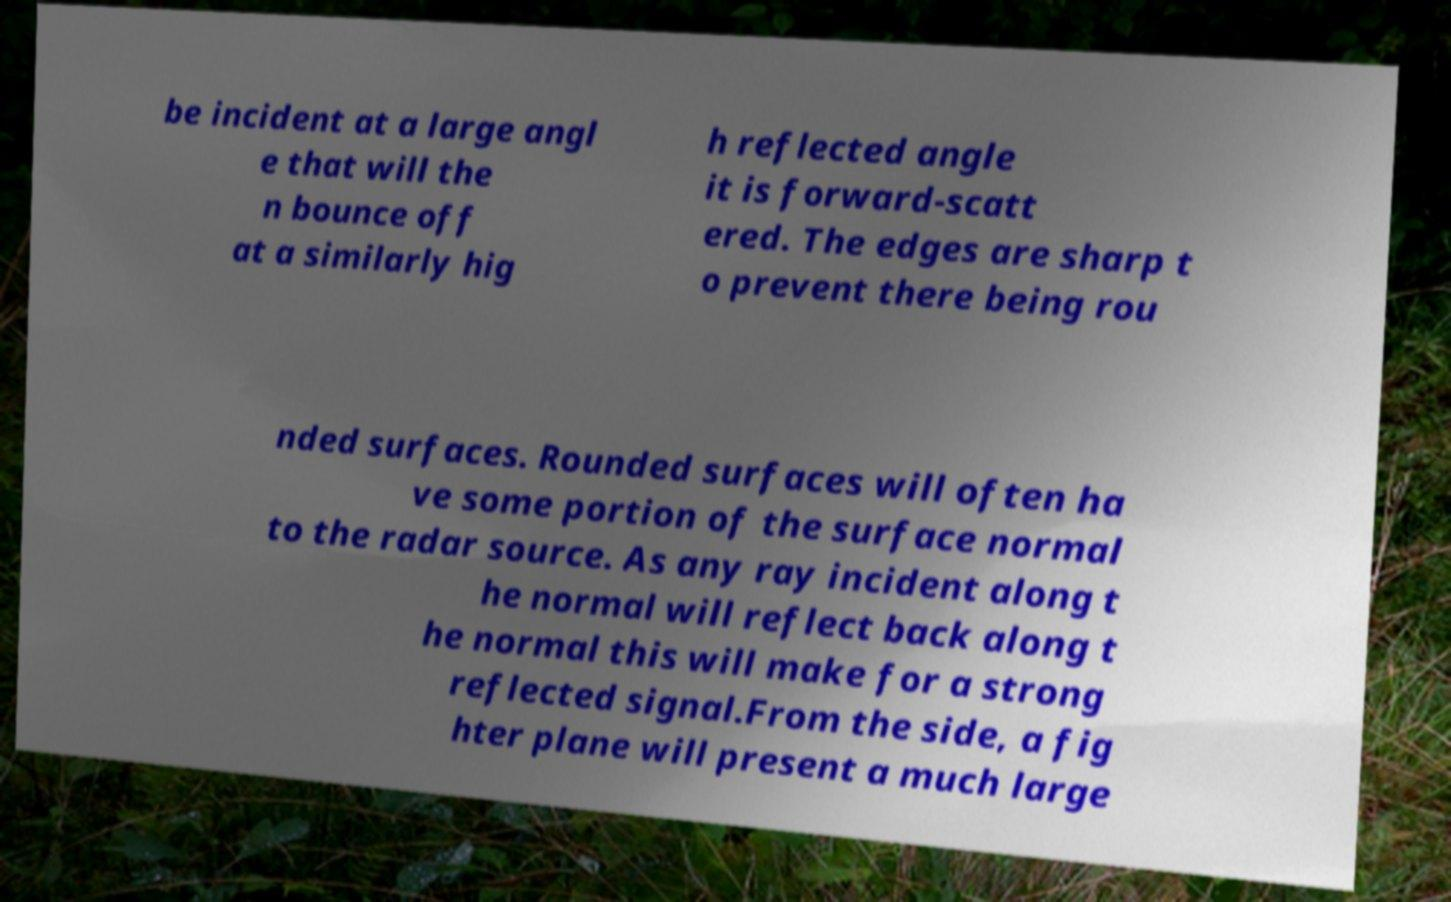Can you accurately transcribe the text from the provided image for me? be incident at a large angl e that will the n bounce off at a similarly hig h reflected angle it is forward-scatt ered. The edges are sharp t o prevent there being rou nded surfaces. Rounded surfaces will often ha ve some portion of the surface normal to the radar source. As any ray incident along t he normal will reflect back along t he normal this will make for a strong reflected signal.From the side, a fig hter plane will present a much large 